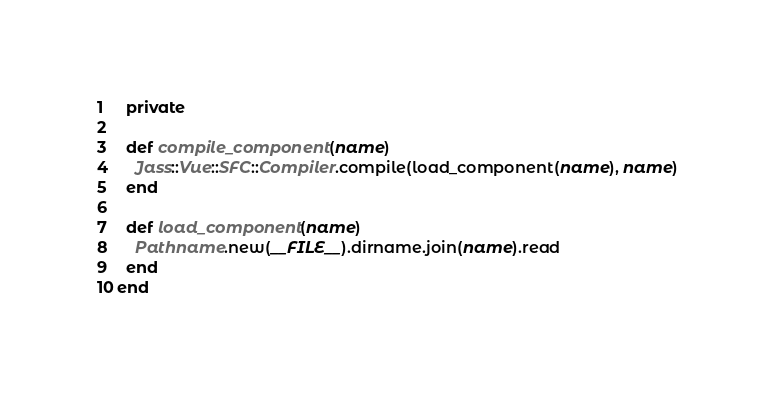Convert code to text. <code><loc_0><loc_0><loc_500><loc_500><_Ruby_>  private
  
  def compile_component(name)
    Jass::Vue::SFC::Compiler.compile(load_component(name), name)
  end
  
  def load_component(name)
    Pathname.new(__FILE__).dirname.join(name).read
  end
end
</code> 